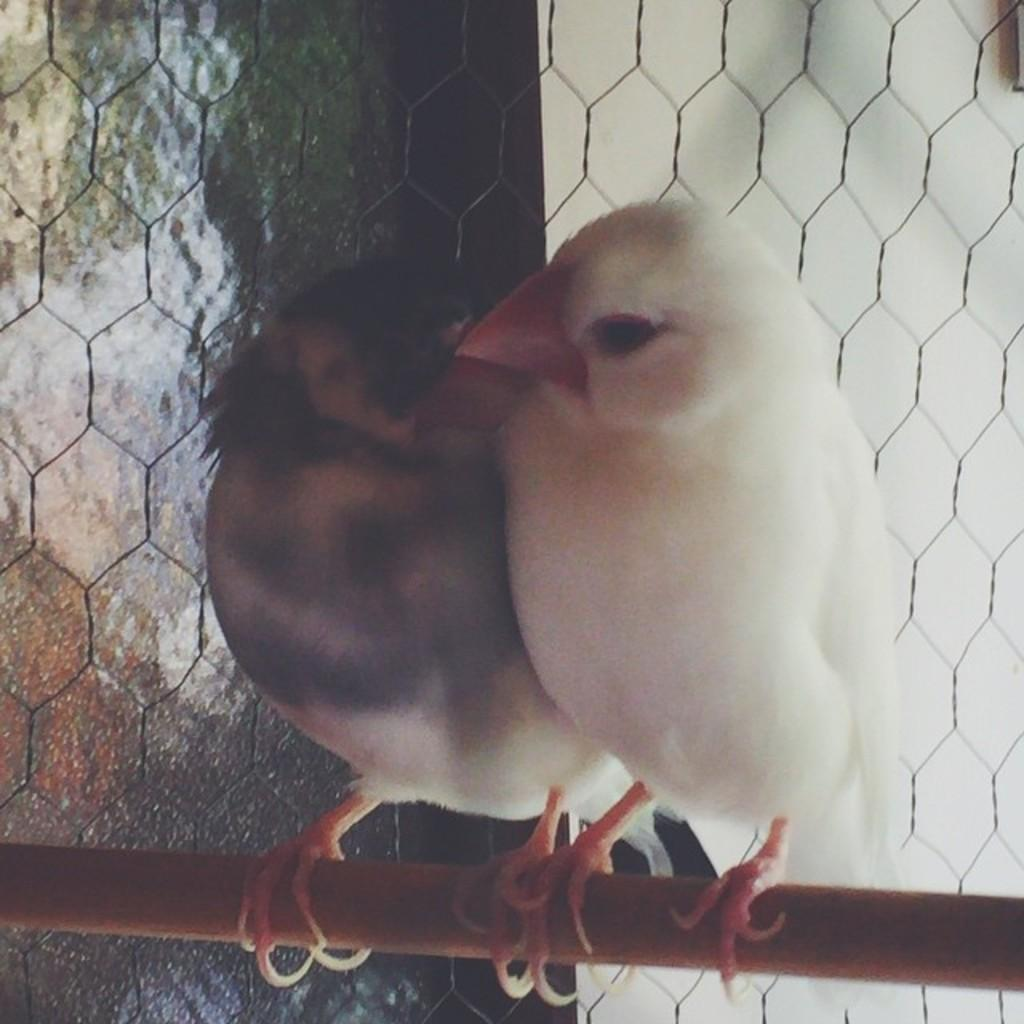How many birds can be seen in the image? There are two birds in the image. What are the birds perched on? The birds are on an object. What can be seen in the background of the image? There is a fence visible in the background of the image. How would you describe the background of the image? The background of the image is blurred. How many oranges are on the bookshelf in the image? There is no bookshelf or orange present in the image. 